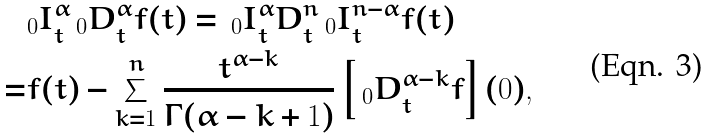<formula> <loc_0><loc_0><loc_500><loc_500>& _ { 0 } I _ { t } ^ { \alpha } \, _ { 0 } D _ { t } ^ { \alpha } f ( t ) = \, _ { 0 } I _ { t } ^ { \alpha } D _ { t } ^ { n } \, _ { 0 } I _ { t } ^ { n - \alpha } f ( t ) \\ = & f ( t ) - \sum _ { k = 1 } ^ { n } \frac { t ^ { \alpha - k } } { \Gamma ( \alpha - k + 1 ) } \left [ \, _ { 0 } D _ { t } ^ { \alpha - k } f \right ] ( 0 ) ,</formula> 